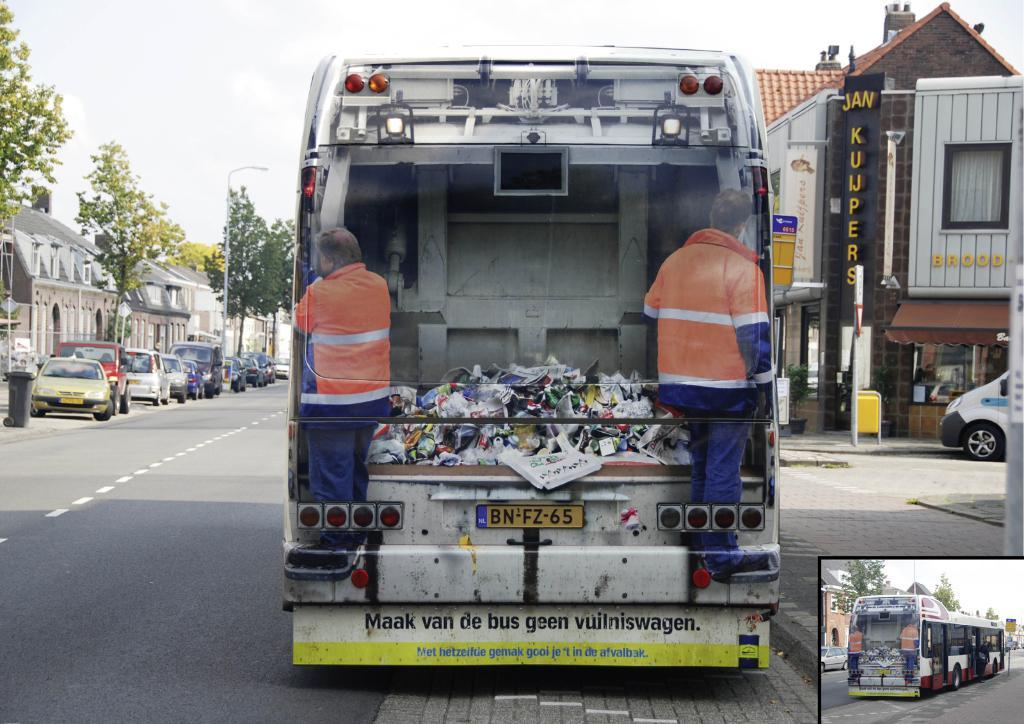What type of vehicles can be seen on the road in the image? There are motor vehicles on the road in the image. Can you describe the condition of one of the motor vehicles? One of the motor vehicles has trash in its carriage. What can be seen in the background of the image? There are trees, buildings, and stores in the background of the image. What color is the toe of the person walking in the image? There is no person walking in the image, and therefore no toe to describe. What type of flesh can be seen in the image? There is no flesh visible in the image. 